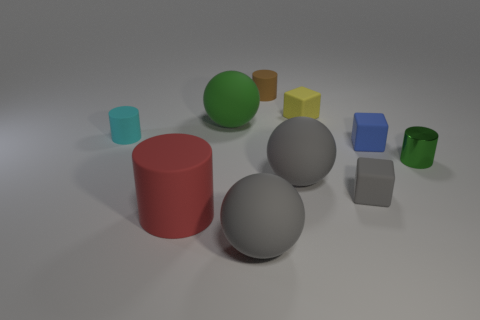Is there a small cyan object that is to the left of the big object behind the green metal thing?
Your answer should be very brief. Yes. There is a small blue rubber object in front of the cyan rubber thing; what is its shape?
Your answer should be very brief. Cube. What material is the large object that is the same color as the small metallic cylinder?
Make the answer very short. Rubber. What is the color of the sphere in front of the matte cube in front of the tiny blue rubber cube?
Ensure brevity in your answer.  Gray. Is the size of the cyan rubber thing the same as the red object?
Give a very brief answer. No. What material is the green thing that is the same shape as the small cyan object?
Your answer should be very brief. Metal. How many gray rubber spheres have the same size as the red cylinder?
Ensure brevity in your answer.  2. There is a big cylinder that is the same material as the blue block; what is its color?
Keep it short and to the point. Red. Is the number of gray cubes less than the number of big brown balls?
Your answer should be compact. No. What number of blue things are blocks or spheres?
Your answer should be very brief. 1. 